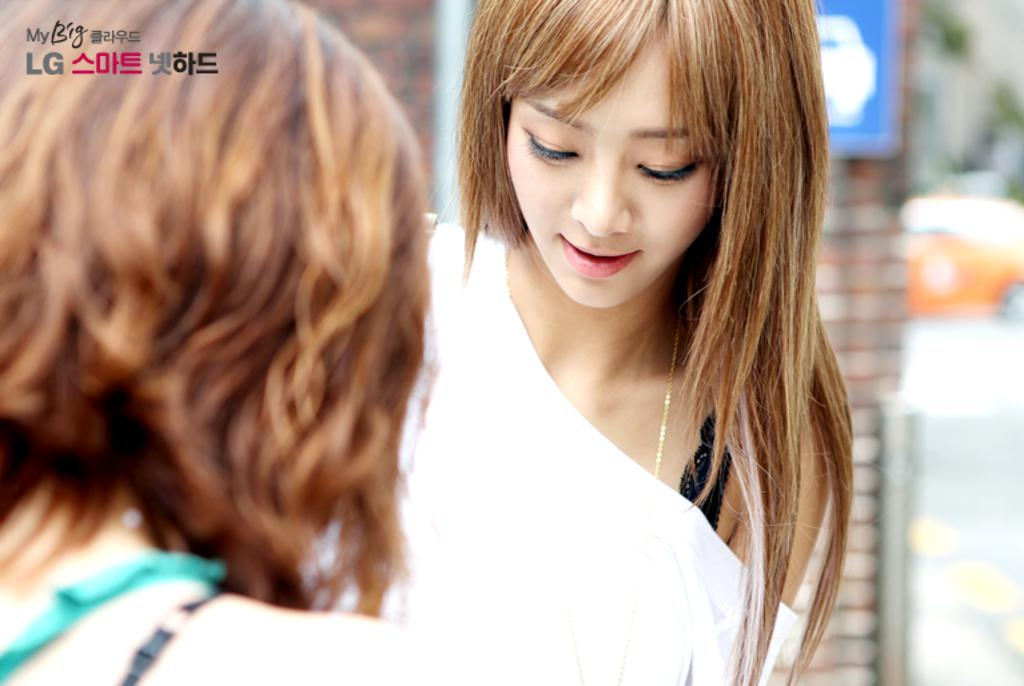How many people are present in the image? There are two women in the image. Can you describe the text at the top left corner of the image? Unfortunately, the provided facts do not give any information about the text in the image. However, we can mention that there is some text present at the top left corner. What type of lettuce is being used as a hat by one of the women in the image? There is no lettuce present in the image, nor is any woman wearing lettuce as a hat. 